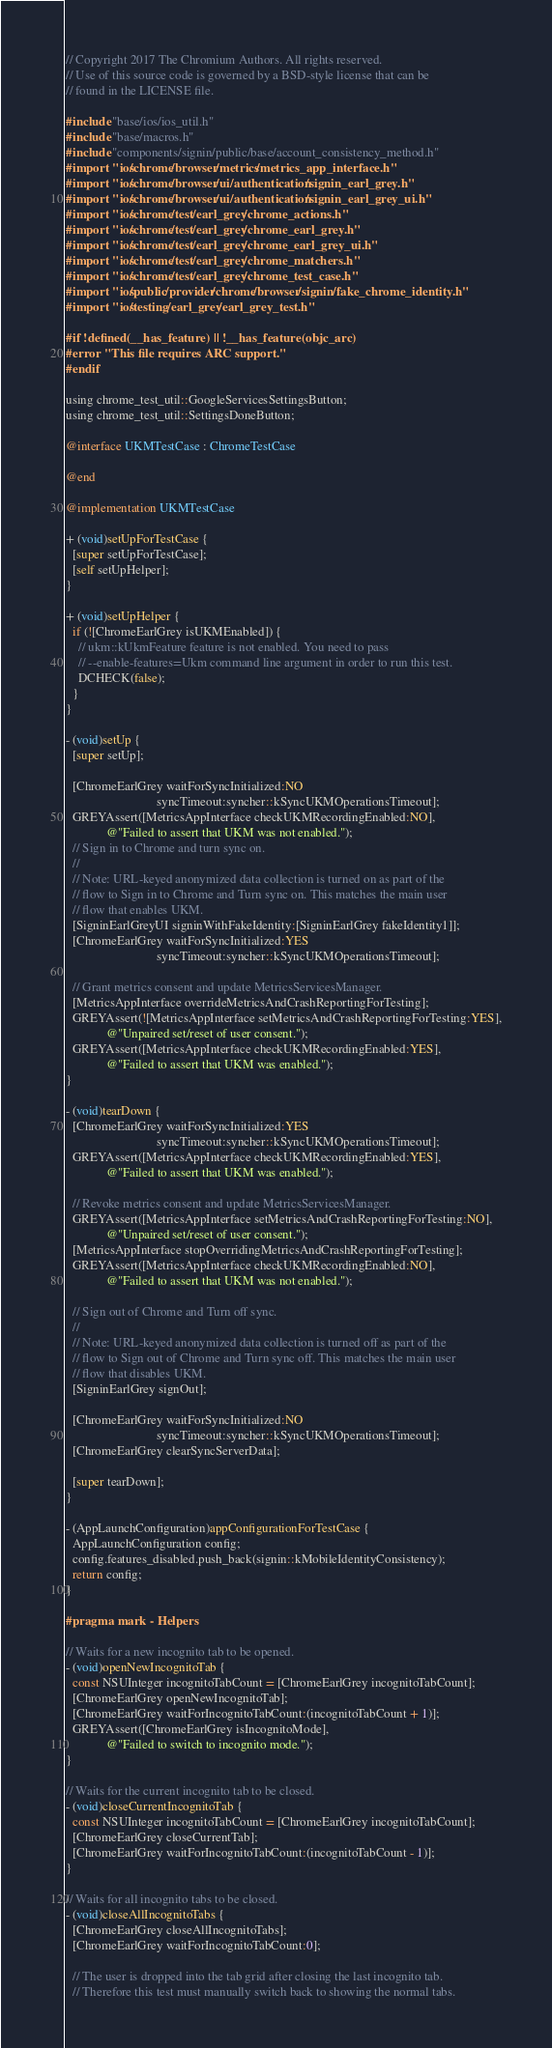Convert code to text. <code><loc_0><loc_0><loc_500><loc_500><_ObjectiveC_>// Copyright 2017 The Chromium Authors. All rights reserved.
// Use of this source code is governed by a BSD-style license that can be
// found in the LICENSE file.

#include "base/ios/ios_util.h"
#include "base/macros.h"
#include "components/signin/public/base/account_consistency_method.h"
#import "ios/chrome/browser/metrics/metrics_app_interface.h"
#import "ios/chrome/browser/ui/authentication/signin_earl_grey.h"
#import "ios/chrome/browser/ui/authentication/signin_earl_grey_ui.h"
#import "ios/chrome/test/earl_grey/chrome_actions.h"
#import "ios/chrome/test/earl_grey/chrome_earl_grey.h"
#import "ios/chrome/test/earl_grey/chrome_earl_grey_ui.h"
#import "ios/chrome/test/earl_grey/chrome_matchers.h"
#import "ios/chrome/test/earl_grey/chrome_test_case.h"
#import "ios/public/provider/chrome/browser/signin/fake_chrome_identity.h"
#import "ios/testing/earl_grey/earl_grey_test.h"

#if !defined(__has_feature) || !__has_feature(objc_arc)
#error "This file requires ARC support."
#endif

using chrome_test_util::GoogleServicesSettingsButton;
using chrome_test_util::SettingsDoneButton;

@interface UKMTestCase : ChromeTestCase

@end

@implementation UKMTestCase

+ (void)setUpForTestCase {
  [super setUpForTestCase];
  [self setUpHelper];
}

+ (void)setUpHelper {
  if (![ChromeEarlGrey isUKMEnabled]) {
    // ukm::kUkmFeature feature is not enabled. You need to pass
    // --enable-features=Ukm command line argument in order to run this test.
    DCHECK(false);
  }
}

- (void)setUp {
  [super setUp];

  [ChromeEarlGrey waitForSyncInitialized:NO
                             syncTimeout:syncher::kSyncUKMOperationsTimeout];
  GREYAssert([MetricsAppInterface checkUKMRecordingEnabled:NO],
             @"Failed to assert that UKM was not enabled.");
  // Sign in to Chrome and turn sync on.
  //
  // Note: URL-keyed anonymized data collection is turned on as part of the
  // flow to Sign in to Chrome and Turn sync on. This matches the main user
  // flow that enables UKM.
  [SigninEarlGreyUI signinWithFakeIdentity:[SigninEarlGrey fakeIdentity1]];
  [ChromeEarlGrey waitForSyncInitialized:YES
                             syncTimeout:syncher::kSyncUKMOperationsTimeout];

  // Grant metrics consent and update MetricsServicesManager.
  [MetricsAppInterface overrideMetricsAndCrashReportingForTesting];
  GREYAssert(![MetricsAppInterface setMetricsAndCrashReportingForTesting:YES],
             @"Unpaired set/reset of user consent.");
  GREYAssert([MetricsAppInterface checkUKMRecordingEnabled:YES],
             @"Failed to assert that UKM was enabled.");
}

- (void)tearDown {
  [ChromeEarlGrey waitForSyncInitialized:YES
                             syncTimeout:syncher::kSyncUKMOperationsTimeout];
  GREYAssert([MetricsAppInterface checkUKMRecordingEnabled:YES],
             @"Failed to assert that UKM was enabled.");

  // Revoke metrics consent and update MetricsServicesManager.
  GREYAssert([MetricsAppInterface setMetricsAndCrashReportingForTesting:NO],
             @"Unpaired set/reset of user consent.");
  [MetricsAppInterface stopOverridingMetricsAndCrashReportingForTesting];
  GREYAssert([MetricsAppInterface checkUKMRecordingEnabled:NO],
             @"Failed to assert that UKM was not enabled.");

  // Sign out of Chrome and Turn off sync.
  //
  // Note: URL-keyed anonymized data collection is turned off as part of the
  // flow to Sign out of Chrome and Turn sync off. This matches the main user
  // flow that disables UKM.
  [SigninEarlGrey signOut];

  [ChromeEarlGrey waitForSyncInitialized:NO
                             syncTimeout:syncher::kSyncUKMOperationsTimeout];
  [ChromeEarlGrey clearSyncServerData];

  [super tearDown];
}

- (AppLaunchConfiguration)appConfigurationForTestCase {
  AppLaunchConfiguration config;
  config.features_disabled.push_back(signin::kMobileIdentityConsistency);
  return config;
}

#pragma mark - Helpers

// Waits for a new incognito tab to be opened.
- (void)openNewIncognitoTab {
  const NSUInteger incognitoTabCount = [ChromeEarlGrey incognitoTabCount];
  [ChromeEarlGrey openNewIncognitoTab];
  [ChromeEarlGrey waitForIncognitoTabCount:(incognitoTabCount + 1)];
  GREYAssert([ChromeEarlGrey isIncognitoMode],
             @"Failed to switch to incognito mode.");
}

// Waits for the current incognito tab to be closed.
- (void)closeCurrentIncognitoTab {
  const NSUInteger incognitoTabCount = [ChromeEarlGrey incognitoTabCount];
  [ChromeEarlGrey closeCurrentTab];
  [ChromeEarlGrey waitForIncognitoTabCount:(incognitoTabCount - 1)];
}

// Waits for all incognito tabs to be closed.
- (void)closeAllIncognitoTabs {
  [ChromeEarlGrey closeAllIncognitoTabs];
  [ChromeEarlGrey waitForIncognitoTabCount:0];

  // The user is dropped into the tab grid after closing the last incognito tab.
  // Therefore this test must manually switch back to showing the normal tabs.</code> 